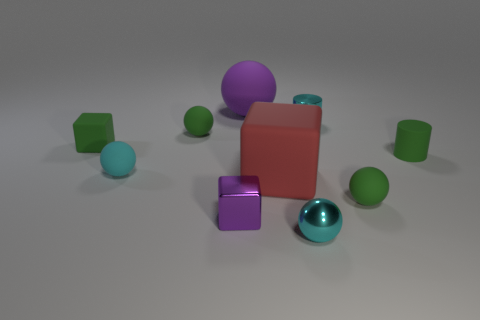What is the size of the cylinder that is the same color as the small rubber cube?
Give a very brief answer. Small. Is there anything else that is the same size as the matte cylinder?
Give a very brief answer. Yes. There is a matte sphere that is both behind the large matte cube and in front of the green cube; what color is it?
Offer a terse response. Cyan. Is the purple object that is behind the big red matte object made of the same material as the large red block?
Offer a very short reply. Yes. There is a metallic ball; is it the same color as the matte block that is right of the tiny purple object?
Provide a short and direct response. No. Are there any tiny matte things behind the tiny shiny ball?
Give a very brief answer. Yes. Does the purple thing right of the purple block have the same size as the cyan thing that is in front of the purple shiny block?
Offer a terse response. No. Is there a green shiny ball that has the same size as the green cube?
Provide a succinct answer. No. Do the small rubber object in front of the red rubber block and the cyan matte object have the same shape?
Offer a very short reply. Yes. There is a sphere that is behind the cyan metal cylinder; what is its material?
Your answer should be compact. Rubber. 